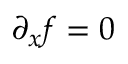<formula> <loc_0><loc_0><loc_500><loc_500>\partial _ { x } f = 0</formula> 